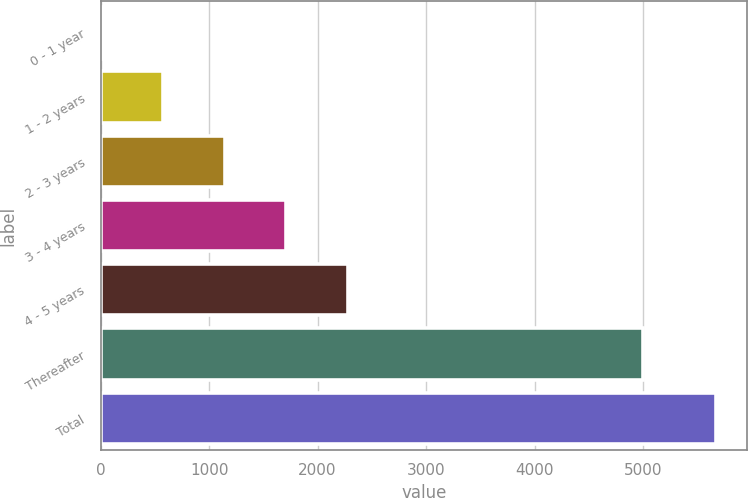Convert chart. <chart><loc_0><loc_0><loc_500><loc_500><bar_chart><fcel>0 - 1 year<fcel>1 - 2 years<fcel>2 - 3 years<fcel>3 - 4 years<fcel>4 - 5 years<fcel>Thereafter<fcel>Total<nl><fcel>13<fcel>579<fcel>1145<fcel>1711<fcel>2277<fcel>4997<fcel>5673<nl></chart> 